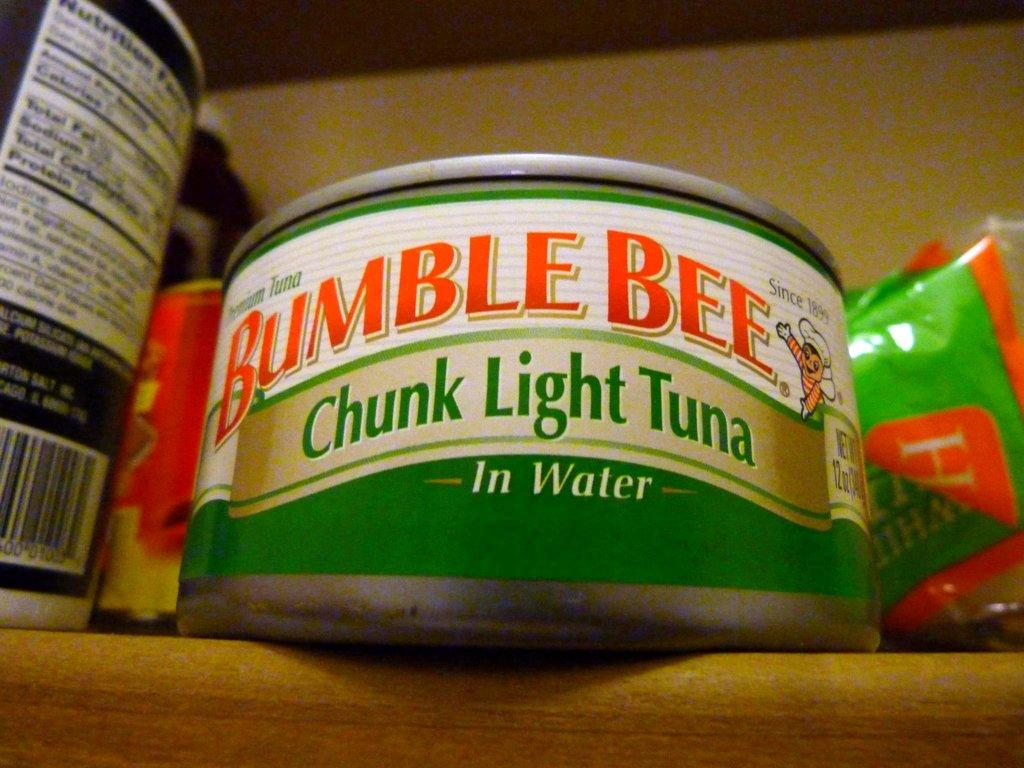<image>
Create a compact narrative representing the image presented. A can of Bumble Bee chunk light tuna on a shelf. 